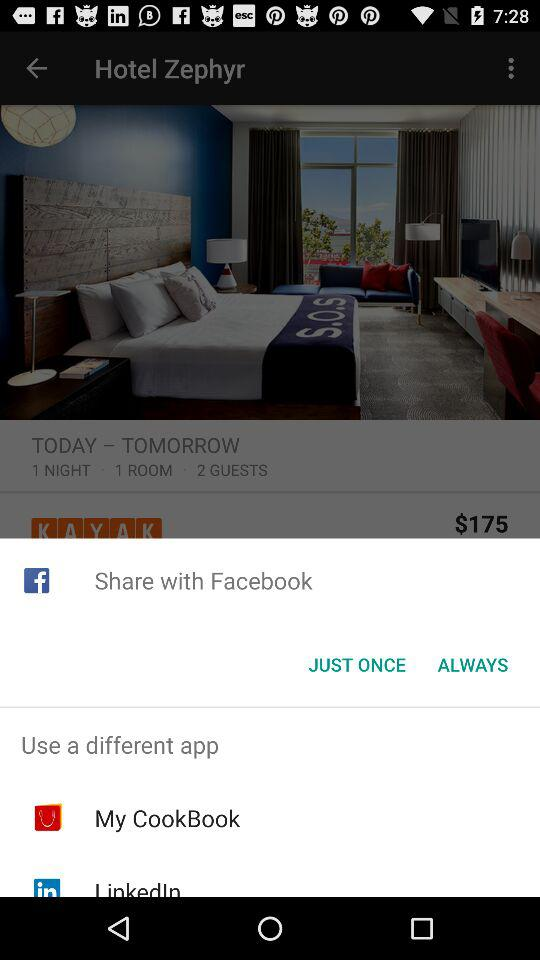What is the hotel name? The hotel name is "Hotel Zephyr". 